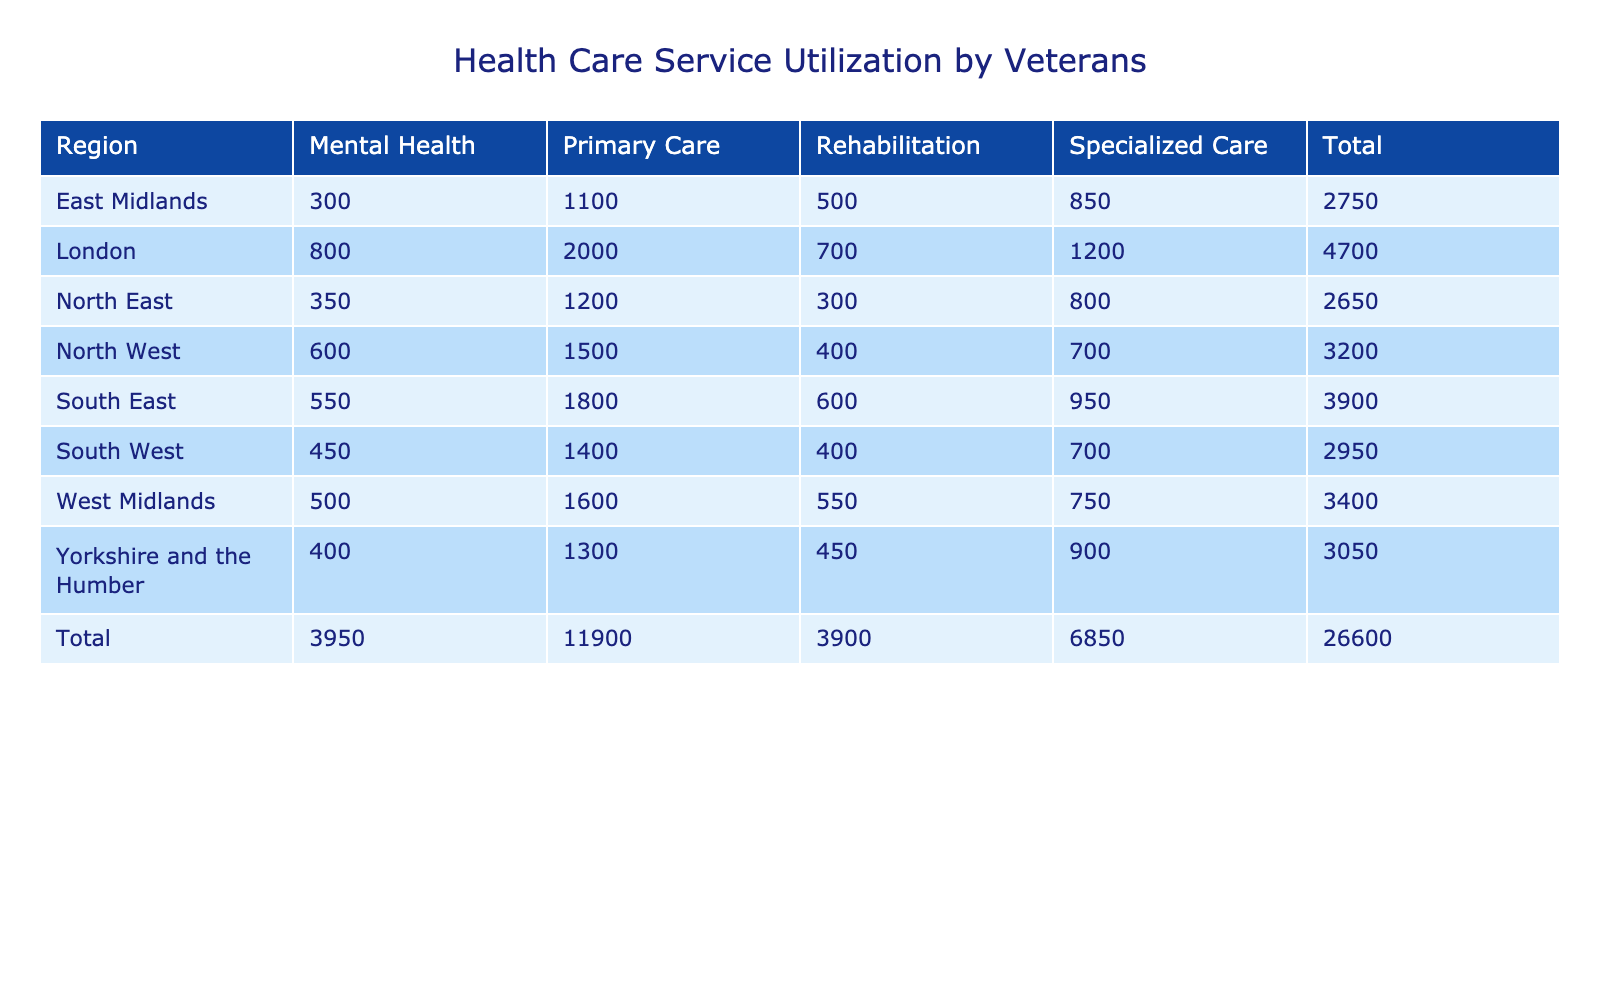What region has the highest number of visits for Mental Health treatment? To find the region with the highest number of visits for Mental Health treatment, we compare the values in the Mental Health column across all regions. The highest value is in London with 800 visits.
Answer: London How many total visits were recorded for Primary Care across all regions? To obtain the total visits for Primary Care, we sum the values in the Primary Care column: 1500 (North West) + 1200 (North East) + 1300 (Yorkshire and the Humber) + 1600 (West Midlands) + 1800 (South East) + 1400 (South West) + 2000 (London) = 10100.
Answer: 10100 Is the number of visits for Specialized Care higher in the North West than the South East? North West has 700 visits for Specialized Care, while South East has 950 visits. Since 700 < 950, the statement is false.
Answer: No What region sees the most visits for Rehabilitation treatment? We look at the Rehabilitation column across the regions and find that the highest number of visits is in the West Midlands with 550 visits.
Answer: West Midlands What is the total number of visits for all types of treatment in Yorkshire and the Humber? Adding the visits for all treatment types in Yorkshire and the Humber: 1300 (Primary Care) + 900 (Specialized Care) + 400 (Mental Health) + 450 (Rehabilitation) = 3050.
Answer: 3050 How does the total number of visits for Specialized Care compare between the East Midlands and the North East? The total visits for Specialized Care in East Midlands is 850, while in North East it is 800. Since 850 > 800, East Midlands has more visits for Specialized Care.
Answer: East Midlands has more visits What is the average number of visits for Rehabilitation treatment across all regions? To find the average for Rehabilitation, we add the visits: 400 (North West) + 300 (North East) + 450 (Yorkshire and the Humber) + 550 (West Midlands) + 500 (East Midlands) + 600 (South East) + 400 (South West) + 700 (London) = 3900. There are 8 regions, so the average is 3900 / 8 = 487.5.
Answer: 487.5 How many visits for Mental Health treatment were recorded in the South West region? Looking under the Mental Health column for the South West, we see 450 visits.
Answer: 450 Which region has the lowest number of visits for specialized care? By examining the values in the Specialized Care column, we see that the North West has 700 visits, which is less than other regions. Therefore, it has the lowest number of visits for Specialized Care.
Answer: North West 